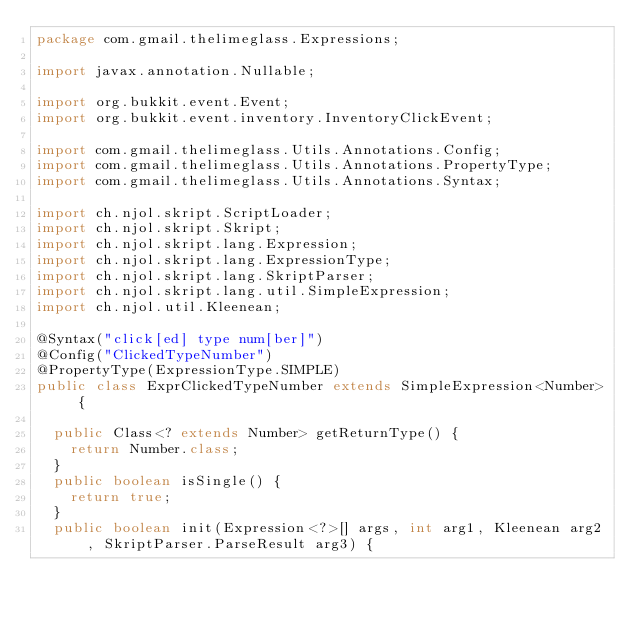<code> <loc_0><loc_0><loc_500><loc_500><_Java_>package com.gmail.thelimeglass.Expressions;

import javax.annotation.Nullable;

import org.bukkit.event.Event;
import org.bukkit.event.inventory.InventoryClickEvent;

import com.gmail.thelimeglass.Utils.Annotations.Config;
import com.gmail.thelimeglass.Utils.Annotations.PropertyType;
import com.gmail.thelimeglass.Utils.Annotations.Syntax;

import ch.njol.skript.ScriptLoader;
import ch.njol.skript.Skript;
import ch.njol.skript.lang.Expression;
import ch.njol.skript.lang.ExpressionType;
import ch.njol.skript.lang.SkriptParser;
import ch.njol.skript.lang.util.SimpleExpression;
import ch.njol.util.Kleenean;

@Syntax("click[ed] type num[ber]")
@Config("ClickedTypeNumber")
@PropertyType(ExpressionType.SIMPLE)
public class ExprClickedTypeNumber extends SimpleExpression<Number> {
	
	public Class<? extends Number> getReturnType() {
		return Number.class;
	}
	public boolean isSingle() {
		return true;
	}
	public boolean init(Expression<?>[] args, int arg1, Kleenean arg2, SkriptParser.ParseResult arg3) {</code> 